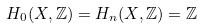Convert formula to latex. <formula><loc_0><loc_0><loc_500><loc_500>H _ { 0 } ( X , \mathbb { Z } ) = H _ { n } ( X , \mathbb { Z } ) = \mathbb { Z }</formula> 